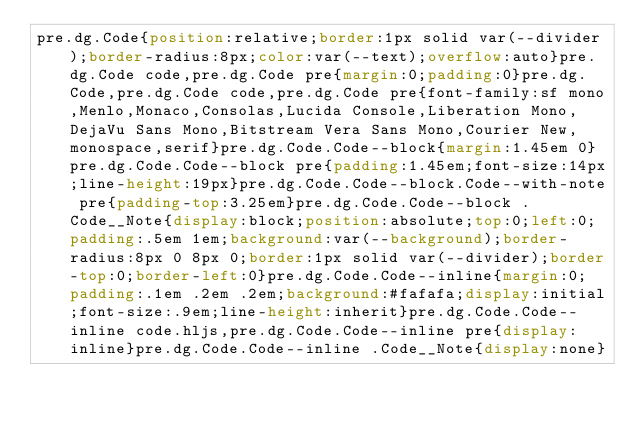<code> <loc_0><loc_0><loc_500><loc_500><_CSS_>pre.dg.Code{position:relative;border:1px solid var(--divider);border-radius:8px;color:var(--text);overflow:auto}pre.dg.Code code,pre.dg.Code pre{margin:0;padding:0}pre.dg.Code,pre.dg.Code code,pre.dg.Code pre{font-family:sf mono,Menlo,Monaco,Consolas,Lucida Console,Liberation Mono,DejaVu Sans Mono,Bitstream Vera Sans Mono,Courier New,monospace,serif}pre.dg.Code.Code--block{margin:1.45em 0}pre.dg.Code.Code--block pre{padding:1.45em;font-size:14px;line-height:19px}pre.dg.Code.Code--block.Code--with-note pre{padding-top:3.25em}pre.dg.Code.Code--block .Code__Note{display:block;position:absolute;top:0;left:0;padding:.5em 1em;background:var(--background);border-radius:8px 0 8px 0;border:1px solid var(--divider);border-top:0;border-left:0}pre.dg.Code.Code--inline{margin:0;padding:.1em .2em .2em;background:#fafafa;display:initial;font-size:.9em;line-height:inherit}pre.dg.Code.Code--inline code.hljs,pre.dg.Code.Code--inline pre{display:inline}pre.dg.Code.Code--inline .Code__Note{display:none}</code> 